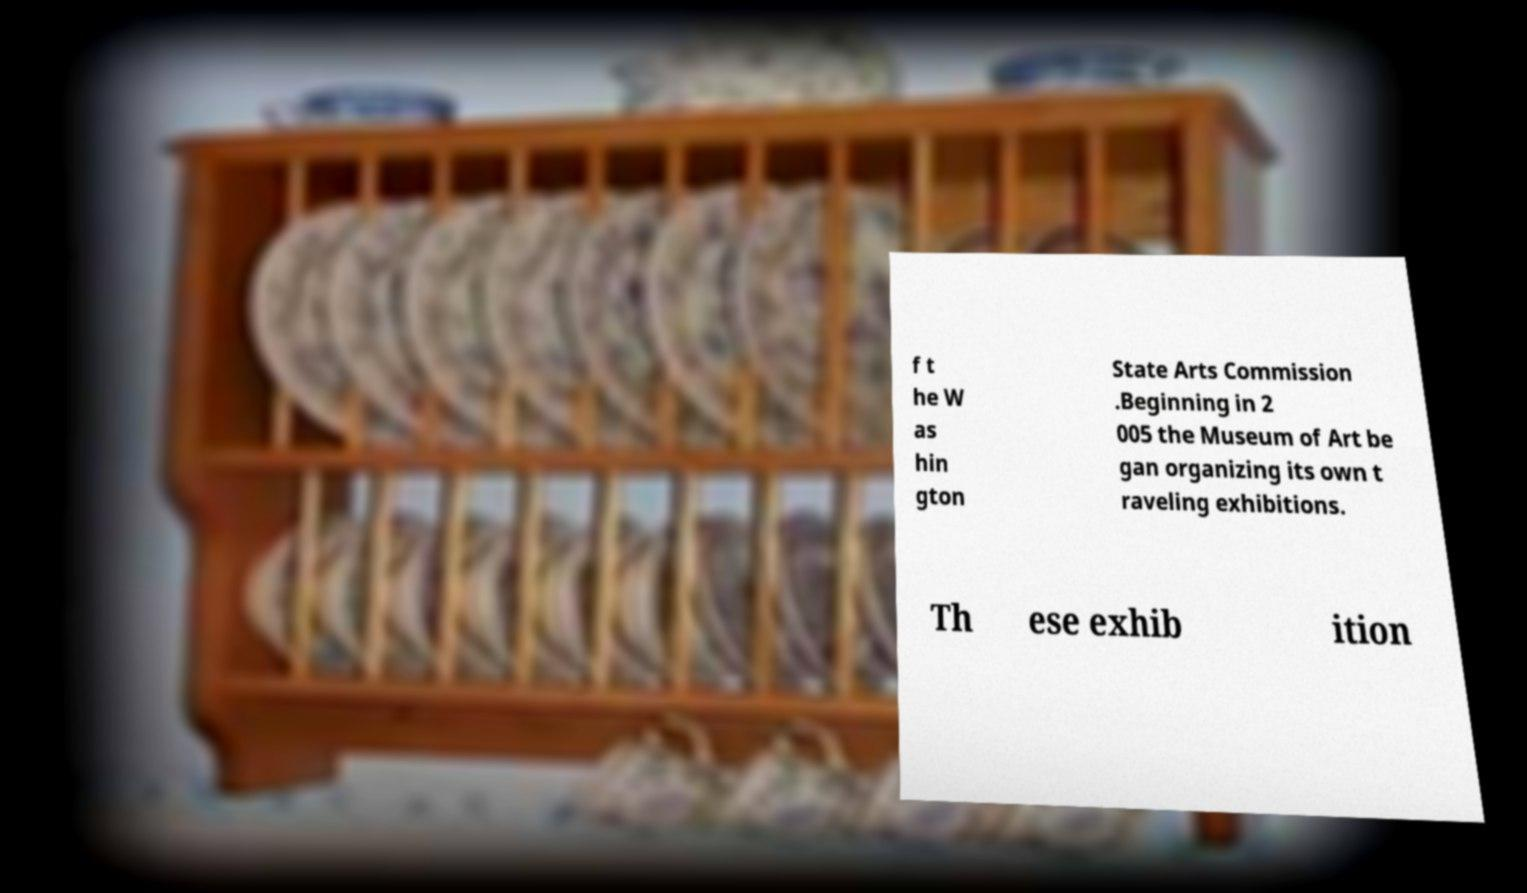Can you read and provide the text displayed in the image?This photo seems to have some interesting text. Can you extract and type it out for me? f t he W as hin gton State Arts Commission .Beginning in 2 005 the Museum of Art be gan organizing its own t raveling exhibitions. Th ese exhib ition 